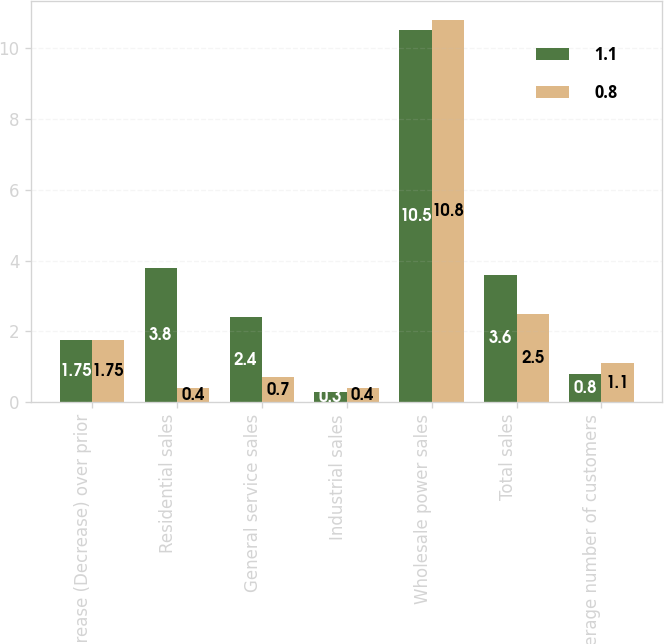Convert chart. <chart><loc_0><loc_0><loc_500><loc_500><stacked_bar_chart><ecel><fcel>Increase (Decrease) over prior<fcel>Residential sales<fcel>General service sales<fcel>Industrial sales<fcel>Wholesale power sales<fcel>Total sales<fcel>Average number of customers<nl><fcel>1.1<fcel>1.75<fcel>3.8<fcel>2.4<fcel>0.3<fcel>10.5<fcel>3.6<fcel>0.8<nl><fcel>0.8<fcel>1.75<fcel>0.4<fcel>0.7<fcel>0.4<fcel>10.8<fcel>2.5<fcel>1.1<nl></chart> 